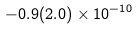Convert formula to latex. <formula><loc_0><loc_0><loc_500><loc_500>- 0 . 9 ( 2 . 0 ) \times 1 0 ^ { - 1 0 }</formula> 